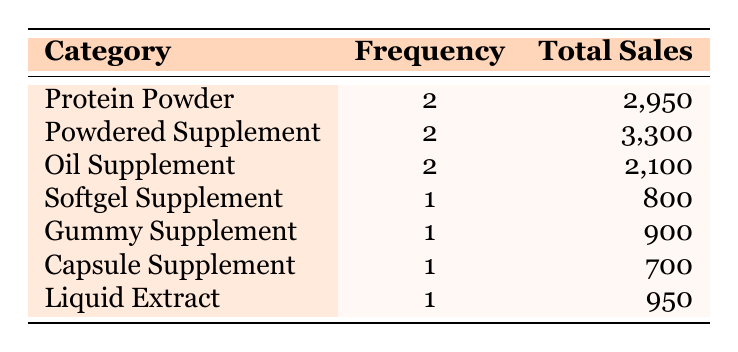What is the total sales for Protein Powder supplements? From the table, there are 2 Protein Powder supplements, with a total sales amounting to 2,950.
Answer: 2,950 How many different categories of pumpkin-based dietary supplements are listed? The table shows a total of 7 different categories: Protein Powder, Powdered Supplement, Oil Supplement, Softgel Supplement, Gummy Supplement, Capsule Supplement, and Liquid Extract.
Answer: 7 What is the category with the highest total sales? Examining the Total Sales column, the Powdered Supplement category has the highest sales with a total of 3,300.
Answer: Powdered Supplement Is there any category that has only one product listed? Yes, the Softgel Supplement, Gummy Supplement, Capsule Supplement, and Liquid Extract categories each have only one product listed, as indicated in the Frequency column.
Answer: Yes What is the average sales for the Oil Supplement category? There are 2 Oil Supplements with a combined total sales of 2,100. To find the average, divide 2,100 by 2, resulting in an average of 1,050 for each Oil Supplement.
Answer: 1,050 What is the difference in total sales between the highest and lowest selling categories? The highest total sales is 3,300 (Powdered Supplement) and the lowest is 700 (Capsule Supplement). The difference is calculated as 3,300 - 700 = 2,600.
Answer: 2,600 How many products are there in the Gummy Supplement category? The table shows that there is only 1 product listed in the Gummy Supplement category.
Answer: 1 Which category has the lowest total sales? By reviewing the Total Sales column, the Capsule Supplement category has the lowest total sales at 700.
Answer: Capsule Supplement 